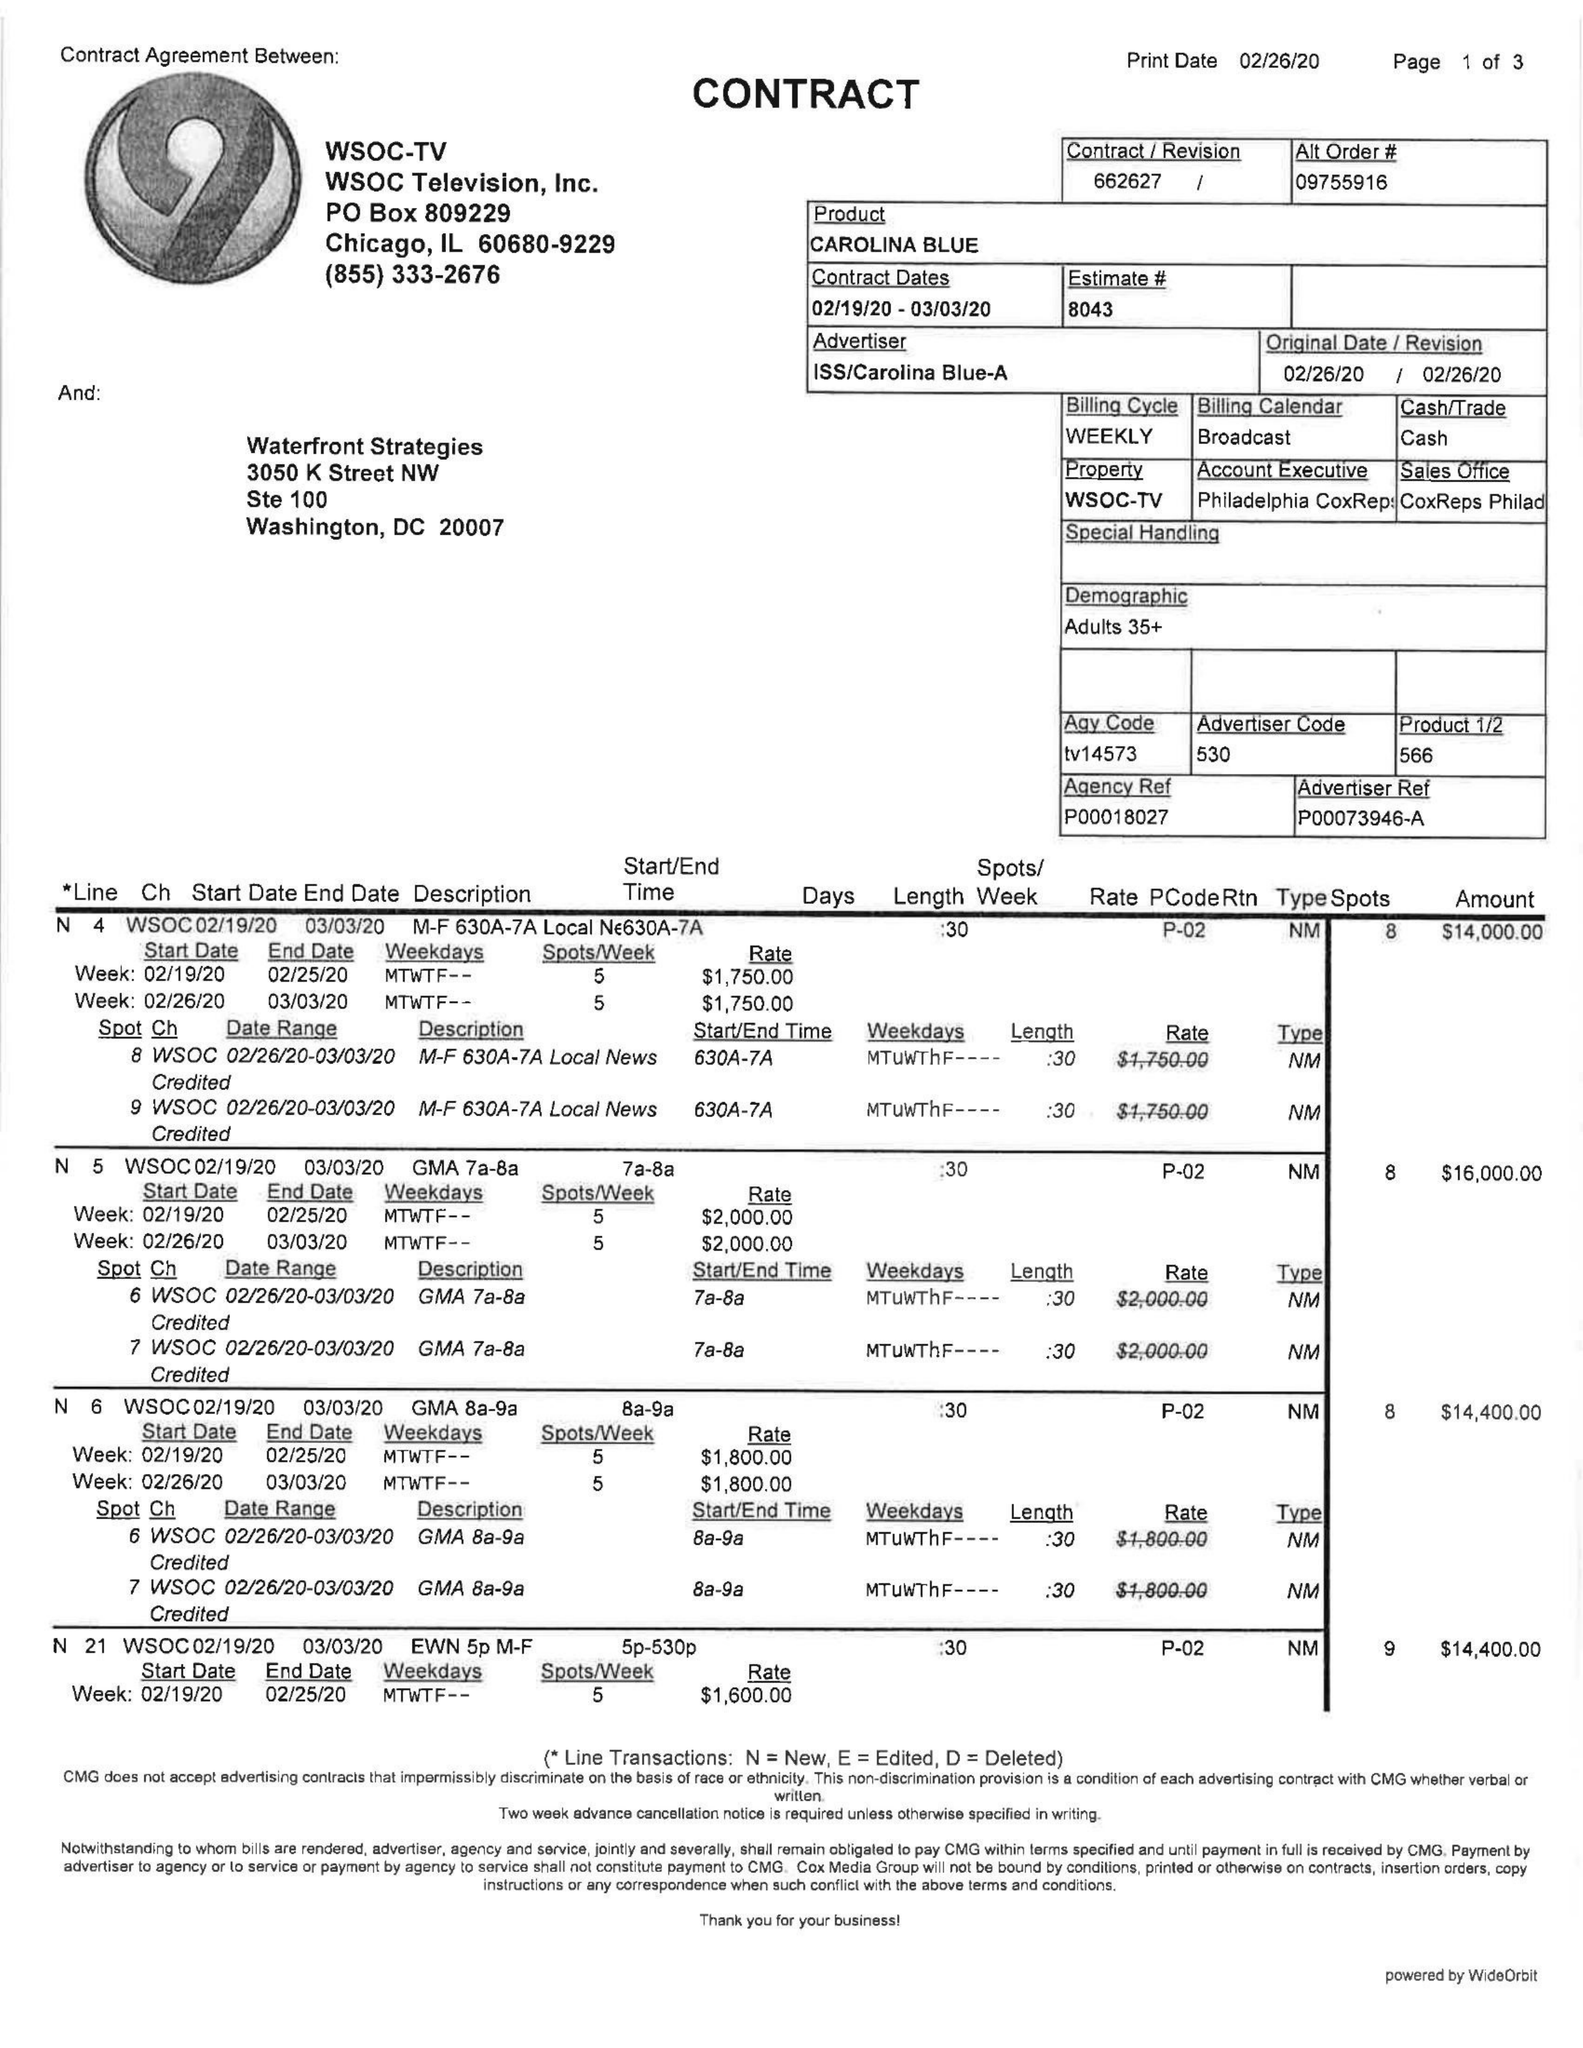What is the value for the contract_num?
Answer the question using a single word or phrase. 662627 